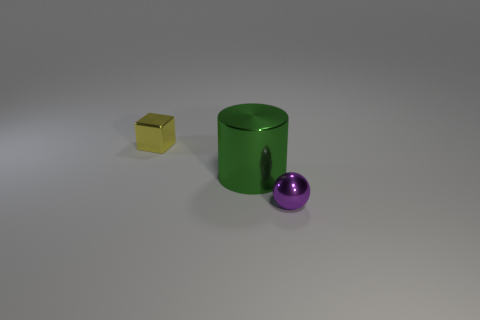Add 1 big green rubber cubes. How many objects exist? 4 Subtract all balls. How many objects are left? 2 Subtract 0 red spheres. How many objects are left? 3 Subtract all small purple metal spheres. Subtract all tiny blue blocks. How many objects are left? 2 Add 1 small yellow blocks. How many small yellow blocks are left? 2 Add 2 purple objects. How many purple objects exist? 3 